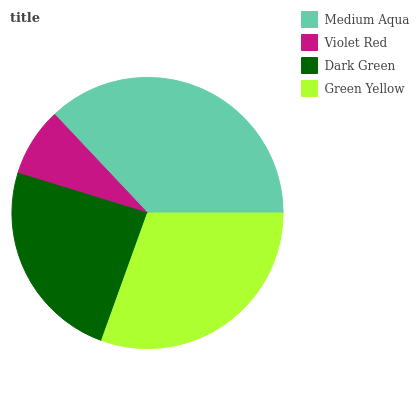Is Violet Red the minimum?
Answer yes or no. Yes. Is Medium Aqua the maximum?
Answer yes or no. Yes. Is Dark Green the minimum?
Answer yes or no. No. Is Dark Green the maximum?
Answer yes or no. No. Is Dark Green greater than Violet Red?
Answer yes or no. Yes. Is Violet Red less than Dark Green?
Answer yes or no. Yes. Is Violet Red greater than Dark Green?
Answer yes or no. No. Is Dark Green less than Violet Red?
Answer yes or no. No. Is Green Yellow the high median?
Answer yes or no. Yes. Is Dark Green the low median?
Answer yes or no. Yes. Is Violet Red the high median?
Answer yes or no. No. Is Medium Aqua the low median?
Answer yes or no. No. 